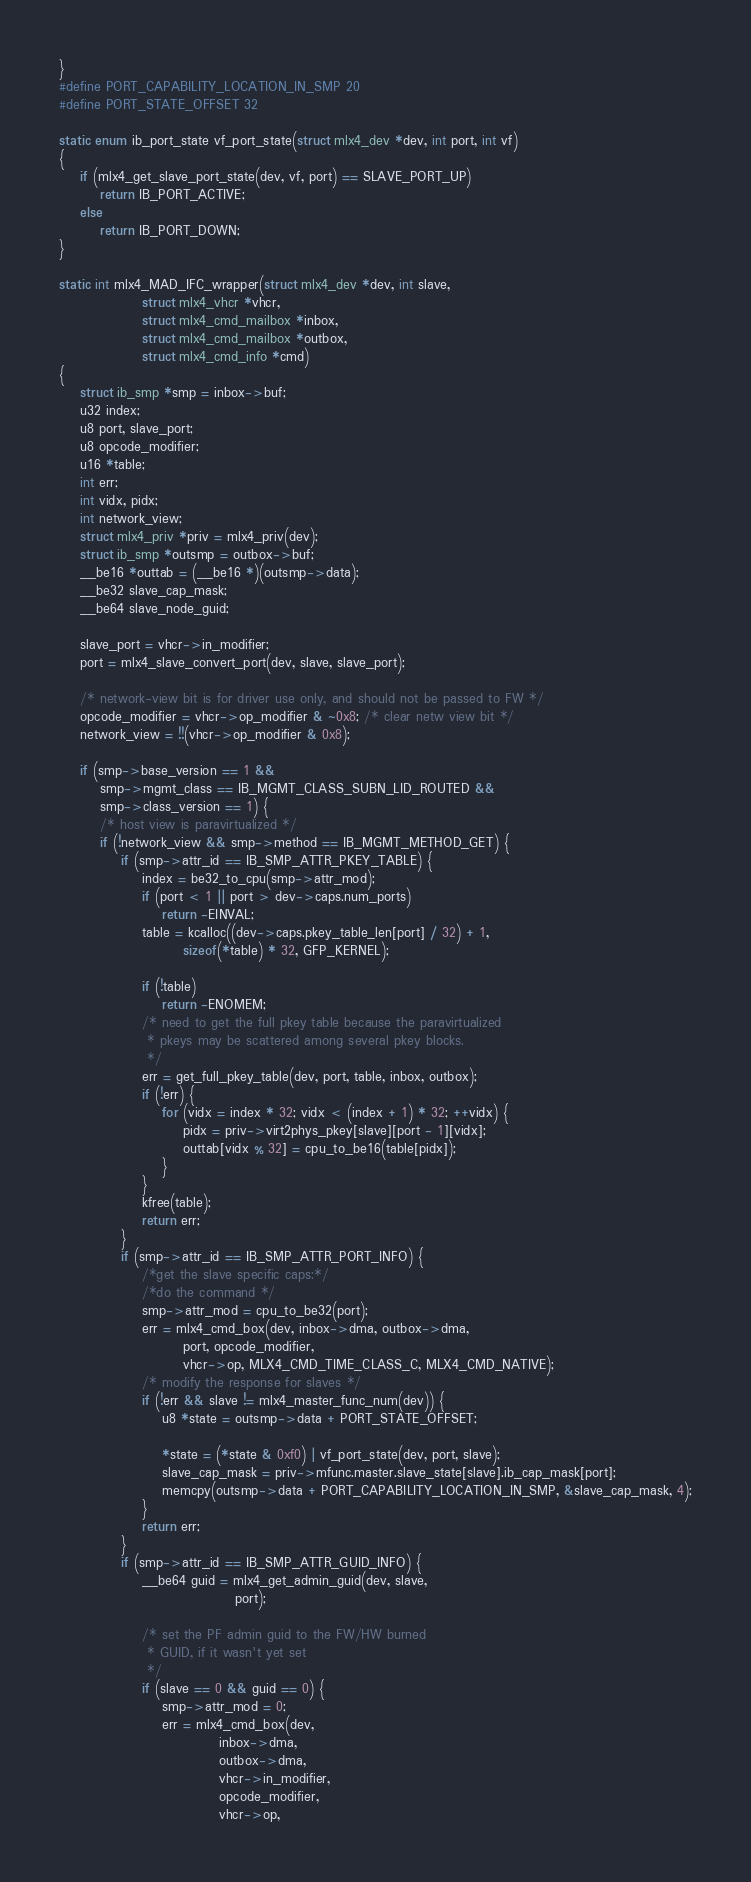<code> <loc_0><loc_0><loc_500><loc_500><_C_>}
#define PORT_CAPABILITY_LOCATION_IN_SMP 20
#define PORT_STATE_OFFSET 32

static enum ib_port_state vf_port_state(struct mlx4_dev *dev, int port, int vf)
{
	if (mlx4_get_slave_port_state(dev, vf, port) == SLAVE_PORT_UP)
		return IB_PORT_ACTIVE;
	else
		return IB_PORT_DOWN;
}

static int mlx4_MAD_IFC_wrapper(struct mlx4_dev *dev, int slave,
				struct mlx4_vhcr *vhcr,
				struct mlx4_cmd_mailbox *inbox,
				struct mlx4_cmd_mailbox *outbox,
				struct mlx4_cmd_info *cmd)
{
	struct ib_smp *smp = inbox->buf;
	u32 index;
	u8 port, slave_port;
	u8 opcode_modifier;
	u16 *table;
	int err;
	int vidx, pidx;
	int network_view;
	struct mlx4_priv *priv = mlx4_priv(dev);
	struct ib_smp *outsmp = outbox->buf;
	__be16 *outtab = (__be16 *)(outsmp->data);
	__be32 slave_cap_mask;
	__be64 slave_node_guid;

	slave_port = vhcr->in_modifier;
	port = mlx4_slave_convert_port(dev, slave, slave_port);

	/* network-view bit is for driver use only, and should not be passed to FW */
	opcode_modifier = vhcr->op_modifier & ~0x8; /* clear netw view bit */
	network_view = !!(vhcr->op_modifier & 0x8);

	if (smp->base_version == 1 &&
	    smp->mgmt_class == IB_MGMT_CLASS_SUBN_LID_ROUTED &&
	    smp->class_version == 1) {
		/* host view is paravirtualized */
		if (!network_view && smp->method == IB_MGMT_METHOD_GET) {
			if (smp->attr_id == IB_SMP_ATTR_PKEY_TABLE) {
				index = be32_to_cpu(smp->attr_mod);
				if (port < 1 || port > dev->caps.num_ports)
					return -EINVAL;
				table = kcalloc((dev->caps.pkey_table_len[port] / 32) + 1,
						sizeof(*table) * 32, GFP_KERNEL);

				if (!table)
					return -ENOMEM;
				/* need to get the full pkey table because the paravirtualized
				 * pkeys may be scattered among several pkey blocks.
				 */
				err = get_full_pkey_table(dev, port, table, inbox, outbox);
				if (!err) {
					for (vidx = index * 32; vidx < (index + 1) * 32; ++vidx) {
						pidx = priv->virt2phys_pkey[slave][port - 1][vidx];
						outtab[vidx % 32] = cpu_to_be16(table[pidx]);
					}
				}
				kfree(table);
				return err;
			}
			if (smp->attr_id == IB_SMP_ATTR_PORT_INFO) {
				/*get the slave specific caps:*/
				/*do the command */
				smp->attr_mod = cpu_to_be32(port);
				err = mlx4_cmd_box(dev, inbox->dma, outbox->dma,
					    port, opcode_modifier,
					    vhcr->op, MLX4_CMD_TIME_CLASS_C, MLX4_CMD_NATIVE);
				/* modify the response for slaves */
				if (!err && slave != mlx4_master_func_num(dev)) {
					u8 *state = outsmp->data + PORT_STATE_OFFSET;

					*state = (*state & 0xf0) | vf_port_state(dev, port, slave);
					slave_cap_mask = priv->mfunc.master.slave_state[slave].ib_cap_mask[port];
					memcpy(outsmp->data + PORT_CAPABILITY_LOCATION_IN_SMP, &slave_cap_mask, 4);
				}
				return err;
			}
			if (smp->attr_id == IB_SMP_ATTR_GUID_INFO) {
				__be64 guid = mlx4_get_admin_guid(dev, slave,
								  port);

				/* set the PF admin guid to the FW/HW burned
				 * GUID, if it wasn't yet set
				 */
				if (slave == 0 && guid == 0) {
					smp->attr_mod = 0;
					err = mlx4_cmd_box(dev,
							   inbox->dma,
							   outbox->dma,
							   vhcr->in_modifier,
							   opcode_modifier,
							   vhcr->op,</code> 